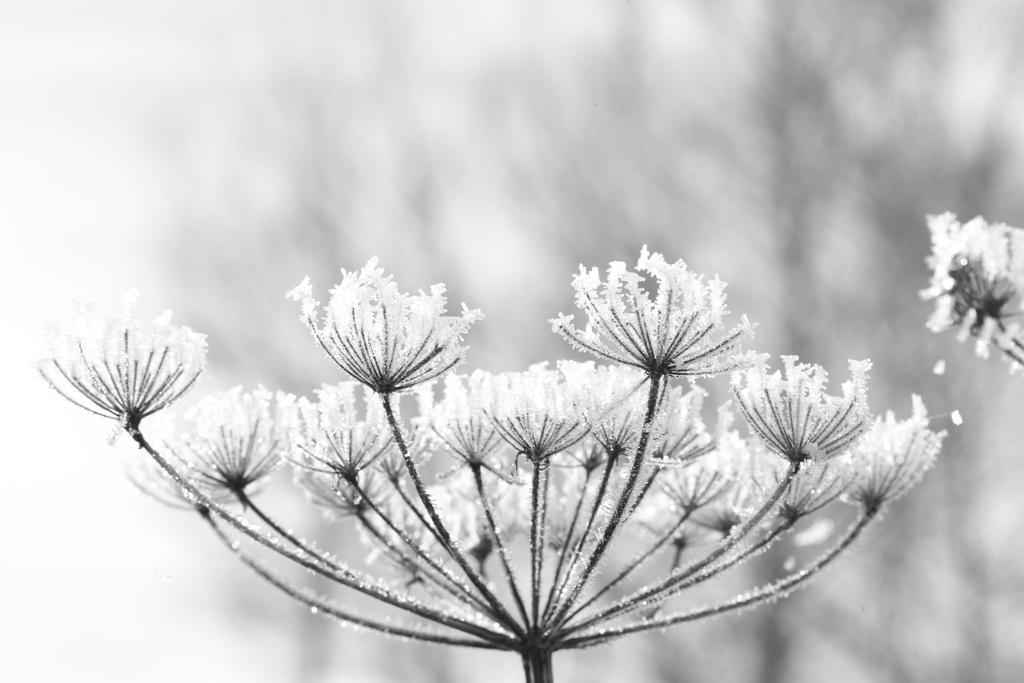What type of flowers are in the image? There is a bunch of white-colored flowers in the image. What type of trade is being conducted with the oatmeal in the image? There is no oatmeal or trade present in the image; it only features a bunch of white-colored flowers. 